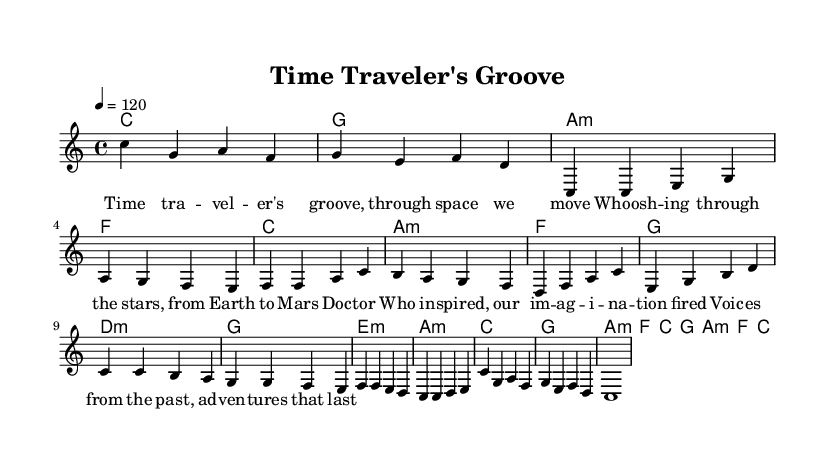What is the key signature of this music? The key signature is C major, which has no sharps or flats indicated on the staff. This is typically found at the beginning of the sheet music.
Answer: C major What is the time signature of this music? The time signature is shown as 4/4, which indicates that there are four beats per measure and the quarter note receives one beat. This information is found at the beginning of the score.
Answer: 4/4 What is the tempo marking provided in the score? The tempo marking indicates a speed of 120 beats per minute (bpm). This is indicated in the tempo instruction located above the staff.
Answer: 120 How many measures are in the chorus section? By examining the measures outlined within the chorus section of the music, we can count a total of four measures. Each measure is separated by vertical bar lines.
Answer: 4 What chord follows the A minor chord in the verse? In the verse section, the sequence of chords reveals that following the A minor chord (a:m), the next chord is F major (f). This can be traced through the chord changes listed alongside the melody.
Answer: F What musical form does this piece primarily follow? The piece primarily follows a verse-chorus structure, where we can identify distinct sections labeled as "Verse," "Pre-Chorus," and "Chorus," reflecting a common pop song format. This structure can be determined through the layout and repetition of sections.
Answer: Verse-chorus What is the general theme of the lyrics based on the provided lines? The general theme of the lyrics revolves around time travel and adventure through space, as indicated by phrases referencing "Time traveler's groove," and "Doc -- tor Who inspired." This thematic analysis can be inferred from the lyrics presented under the melody.
Answer: Time travel 